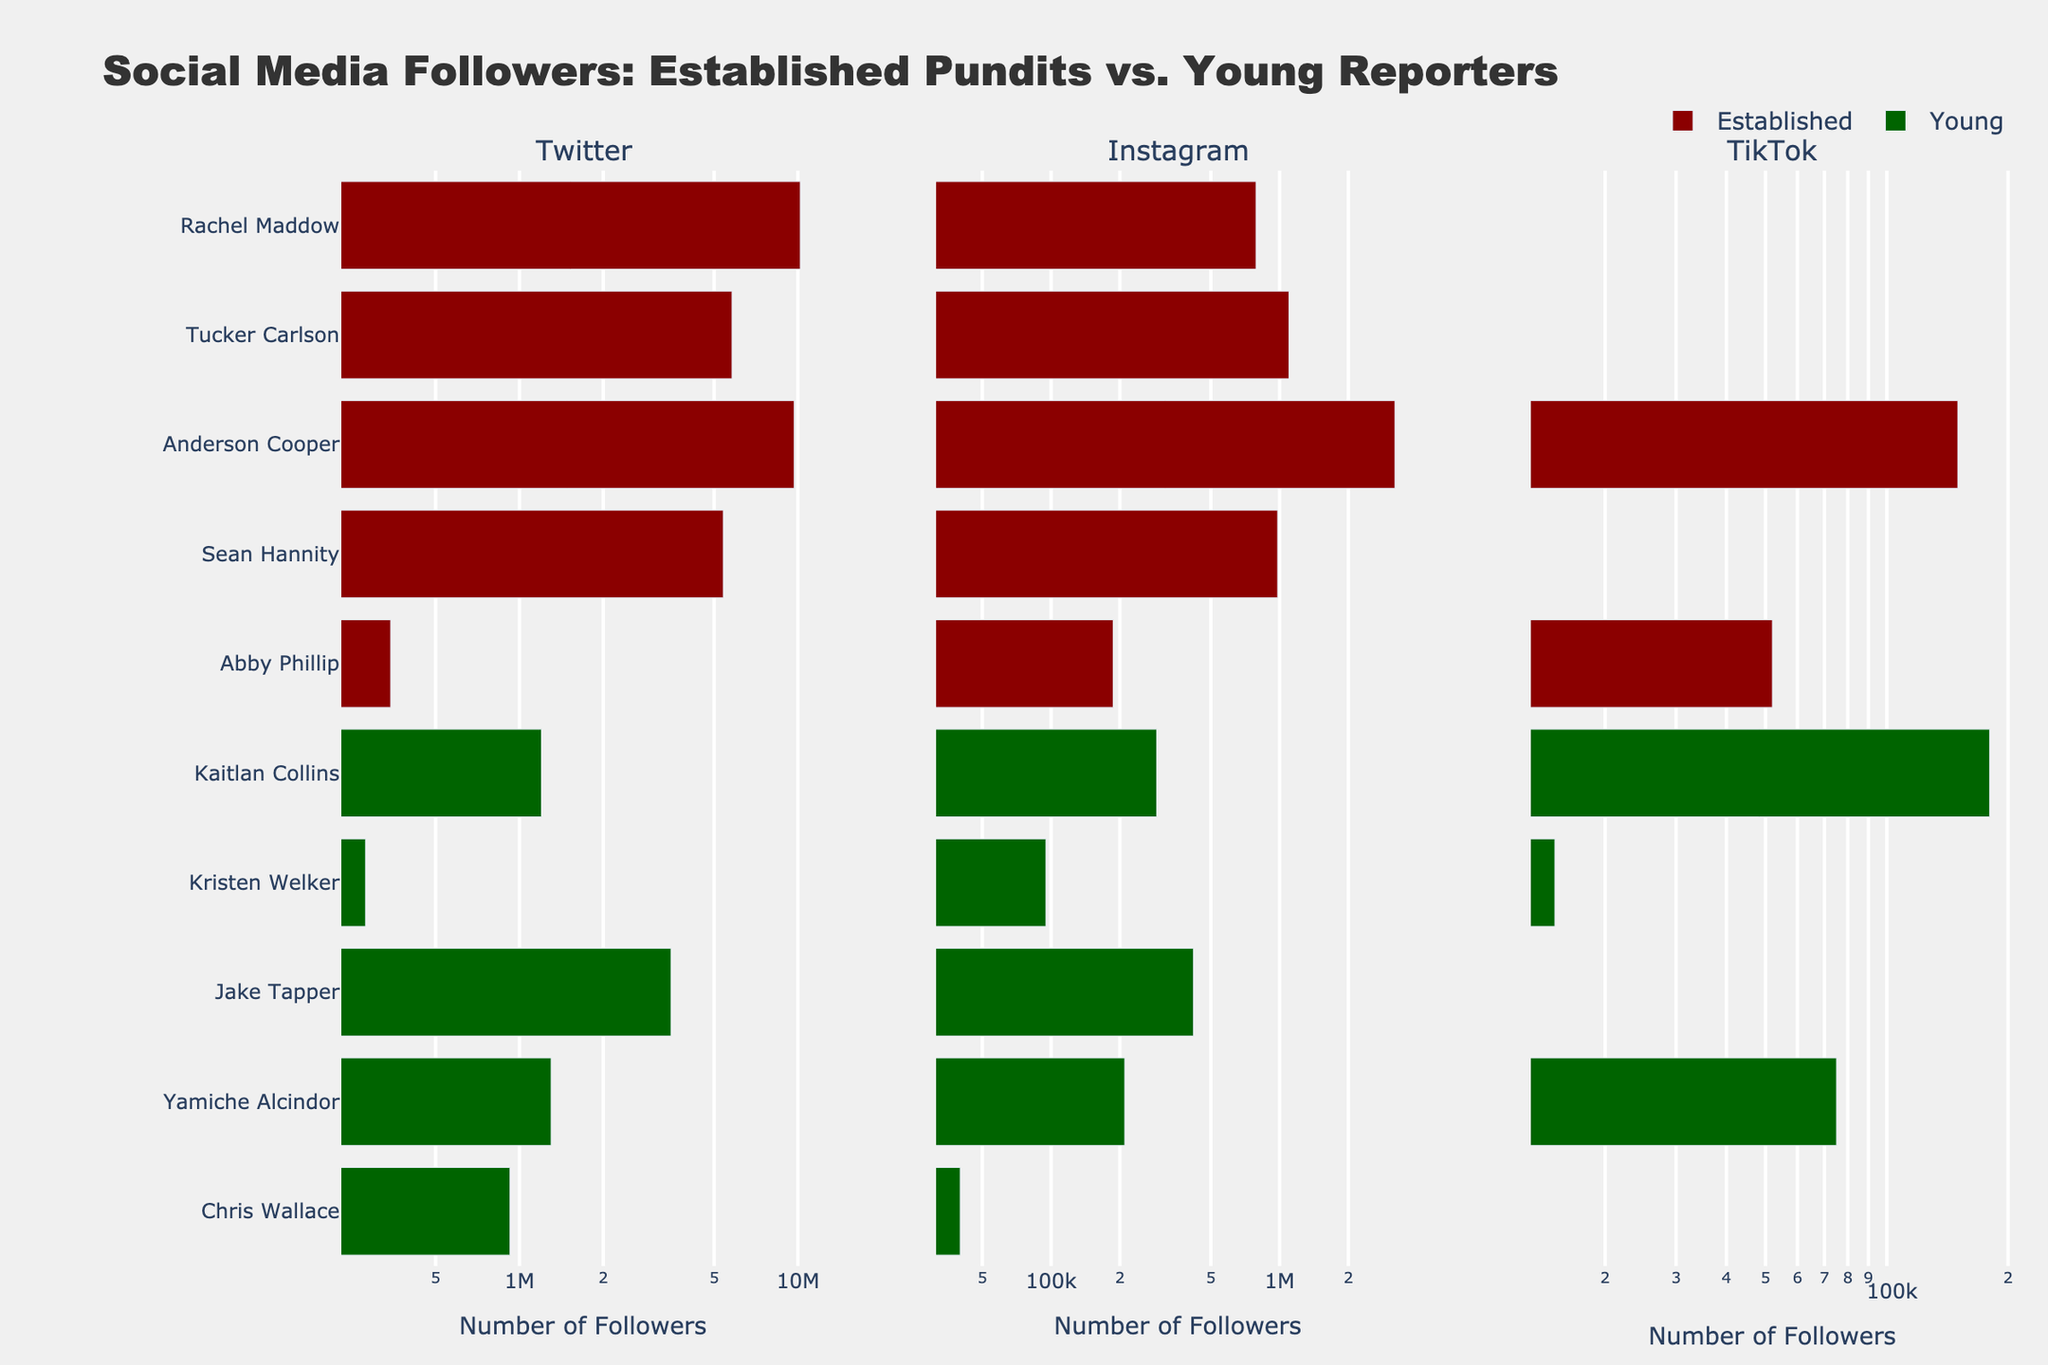What's the total number of Twitter followers for all established pundits? Add the Twitter followers for all established pundits: Rachel Maddow (10,200,000) + Tucker Carlson (5,800,000) + Anderson Cooper (9,700,000) + Sean Hannity (5,400,000) + Jake Tapper (3,500,000) = 34,600,000
Answer: 34,600,000 Who among the young reporters has the most Instagram followers? Among the young reporters, compare the Instagram followers: Abby Phillip (187,000), Kaitlan Collins (290,000), Kristen Welker (95,000), Yamiche Alcindor (210,000), and Chris Wallace (40,000). Kaitlan Collins has the most followers.
Answer: Kaitlan Collins Which group has a higher median number of TikTok followers, established pundits or young reporters? Established pundits have values {0, 0, 0, 0, 150,000}. Young reporters have values {52,000, 180,000, 15,000, 75,000, 0}. The median value for established pundits is 0 and for young reporters is 52,000. Young reporters have a higher median.
Answer: Young reporters What is the difference in the number of Instagram followers between Tucker Carlson and Abby Phillip? Tucker Carlson has 1,100,000 Instagram followers, and Abby Phillip has 187,000 Instagram followers. The difference is 1,100,000 - 187,000 = 913,000
Answer: 913,000 Compare the total Twitter followers for young reporters to that of Anderson Cooper. Which is higher? The total Twitter followers for young reporters: Abby Phillip (345,000) + Kaitlan Collins (1,200,000) + Kristen Welker (280,000) + Yamiche Alcindor (1,300,000) + Chris Wallace (925,000) = 4,050,000. Anderson Cooper has 9,700,000 Twitter followers. Anderson Cooper has higher followers.
Answer: Anderson Cooper Which established pundit has the fewest TikTok followers? Among established pundits, Rachel Maddow (0), Tucker Carlson (0), Anderson Cooper (150,000), Sean Hannity (0), and Jake Tapper (0), Rachel Maddow, Tucker Carlson, Sean Hannity, and Jake Tapper have 0 TikTok followers.
Answer: Rachel Maddow, Tucker Carlson, Sean Hannity, Jake Tapper What is the average number of Instagram followers for all young reporters? The Instagram followers for young reporters are: Abby Phillip (187,000), Kaitlan Collins (290,000), Kristen Welker (95,000), Yamiche Alcindor (210,000), Chris Wallace (40,000). The sum is 187,000 + 290,000 + 95,000 + 210,000 + 40,000 = 822,000. Average = 822,000 / 5 = 164,400
Answer: 164,400 